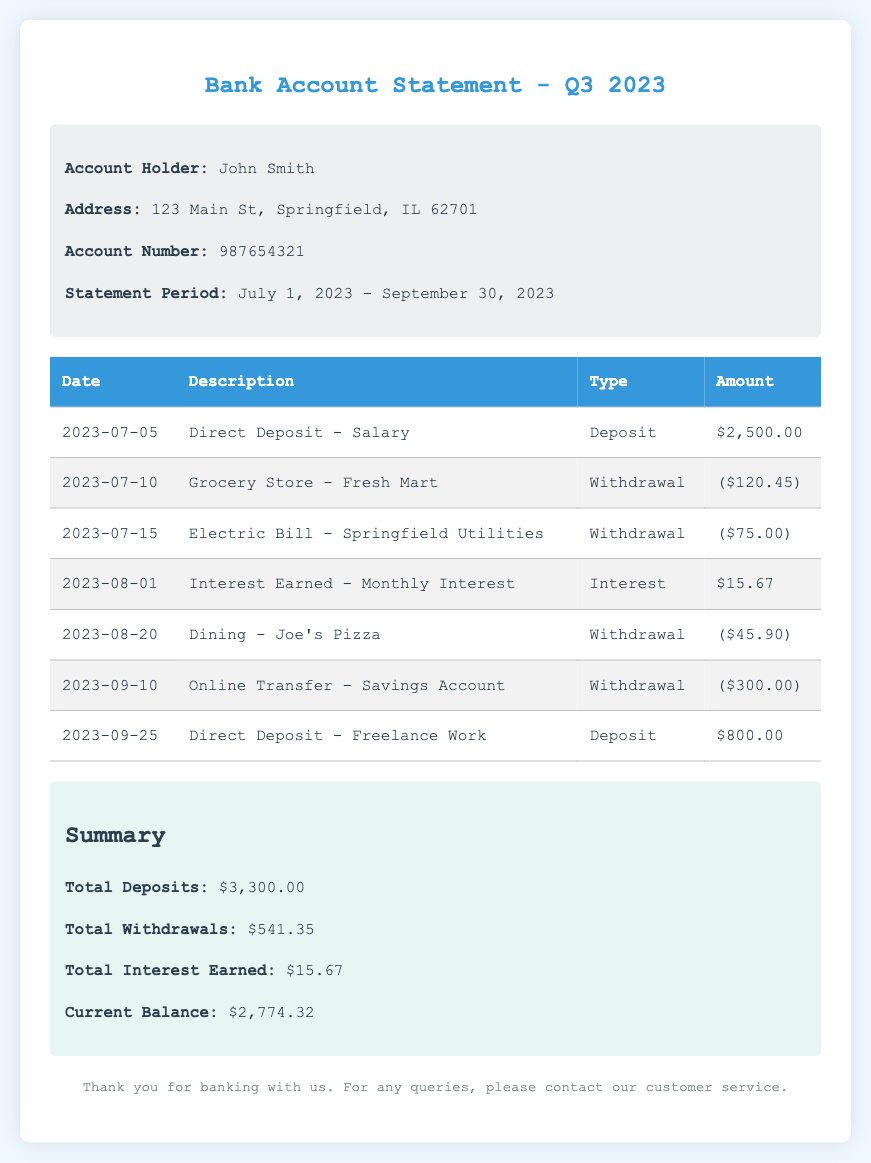What is the account holder's name? The document clearly states the account holder's name as John Smith.
Answer: John Smith What is the statement period? The statement covers transactions from July 1, 2023, to September 30, 2023, as specified in the document.
Answer: July 1, 2023 - September 30, 2023 What was the total amount withdrawn? The total withdrawals are summed up from the withdrawal entries in the table and stated in the summary.
Answer: $541.35 How much interest was earned during the statement period? The interest earned is listed as $15.67 in the summary section of the document.
Answer: $15.67 What was the balance at the end of the statement period? The current balance is provided in the summary, representing the total after all deposits and withdrawals.
Answer: $2,774.32 How many deposits were made in Q3 2023? There are two specific deposits listed in the transaction table, indicating the deposits made during the period.
Answer: 2 What was the date of the first withdrawal? The first withdrawal transaction in the table is dated July 10, 2023.
Answer: July 10, 2023 What type of document is this? The title and content indicate that this is a bank account statement summarizing transactions for a specific period.
Answer: Bank Account Statement What is the description for the interest earned? The interest earned is described as "Monthly Interest" in the transaction table.
Answer: Monthly Interest 